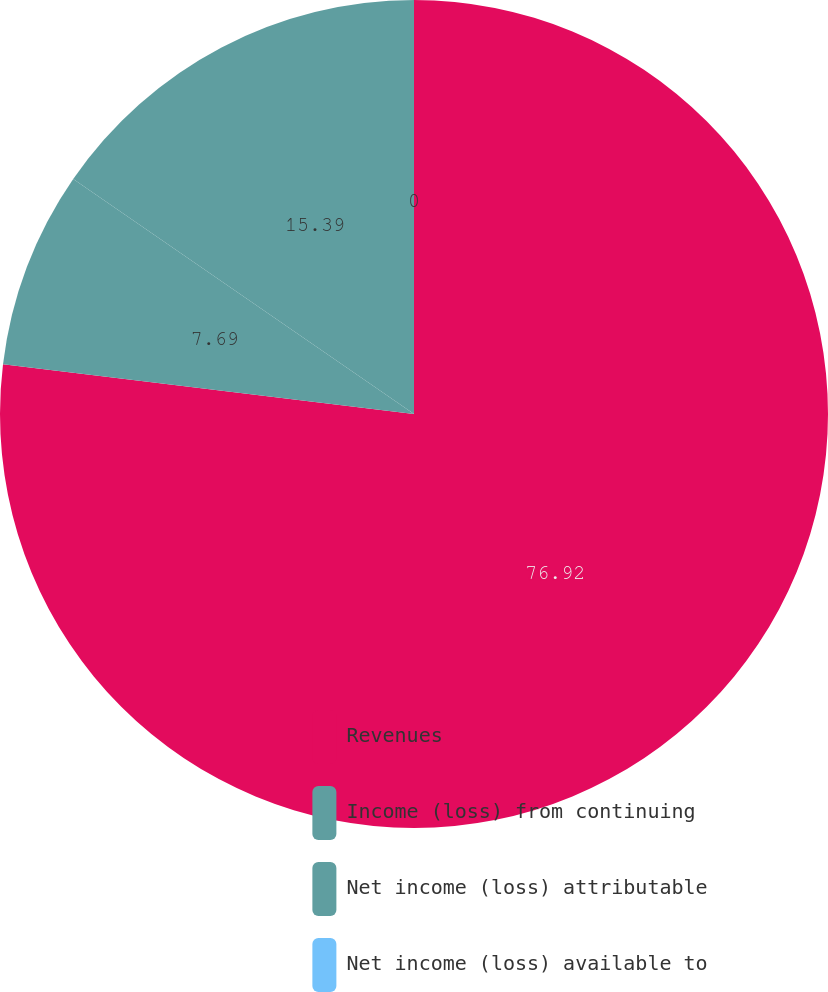<chart> <loc_0><loc_0><loc_500><loc_500><pie_chart><fcel>Revenues<fcel>Income (loss) from continuing<fcel>Net income (loss) attributable<fcel>Net income (loss) available to<nl><fcel>76.92%<fcel>7.69%<fcel>15.39%<fcel>0.0%<nl></chart> 